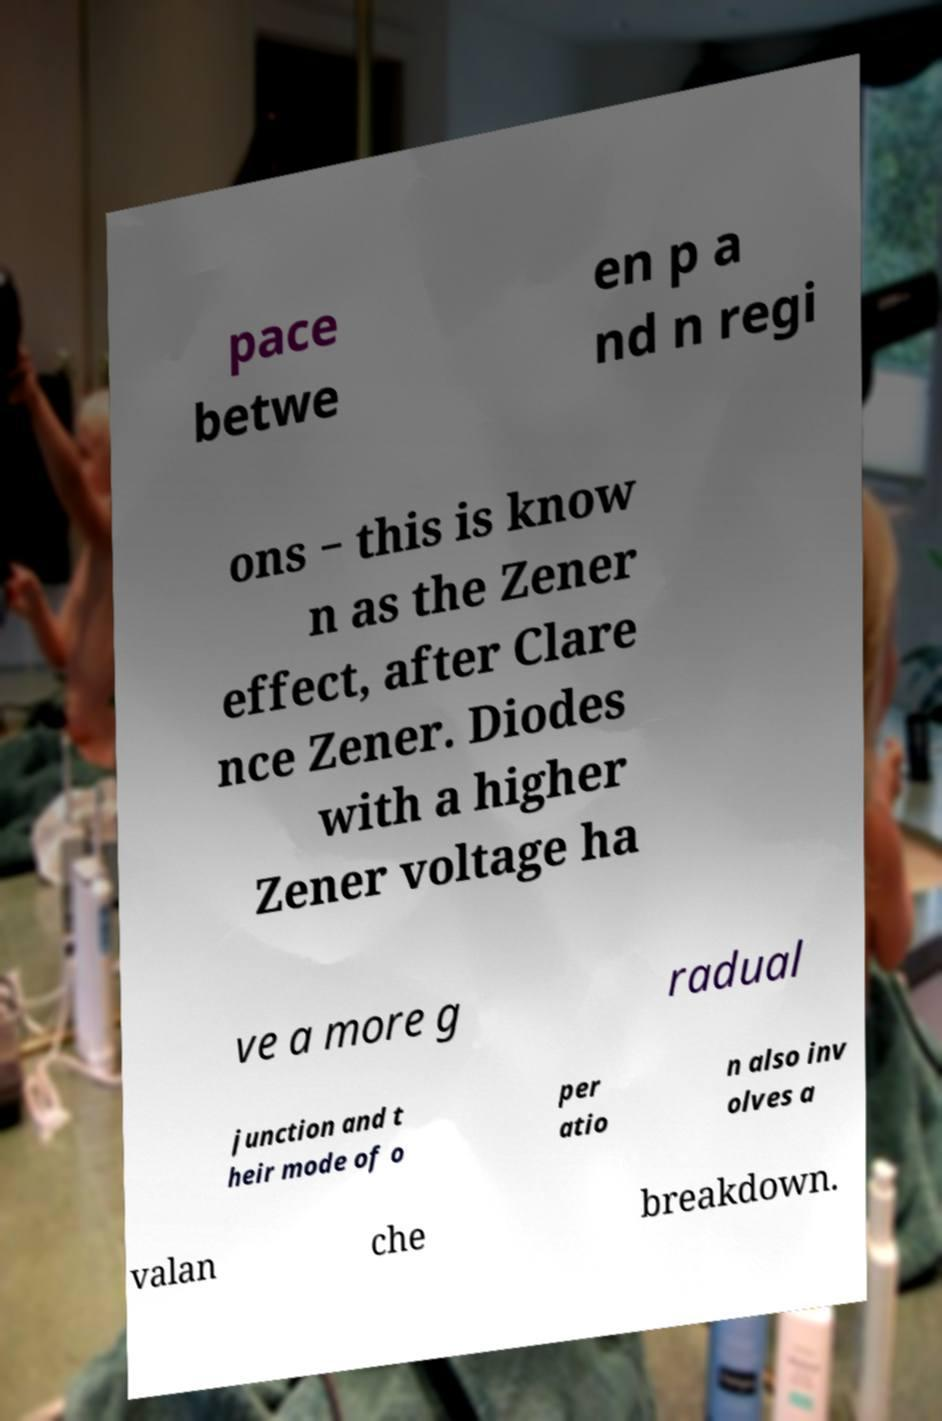Could you assist in decoding the text presented in this image and type it out clearly? pace betwe en p a nd n regi ons − this is know n as the Zener effect, after Clare nce Zener. Diodes with a higher Zener voltage ha ve a more g radual junction and t heir mode of o per atio n also inv olves a valan che breakdown. 